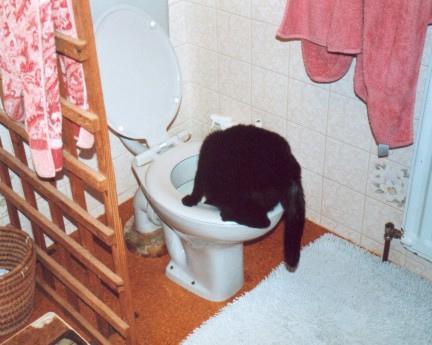How many elephants are pictured here?
Give a very brief answer. 0. 